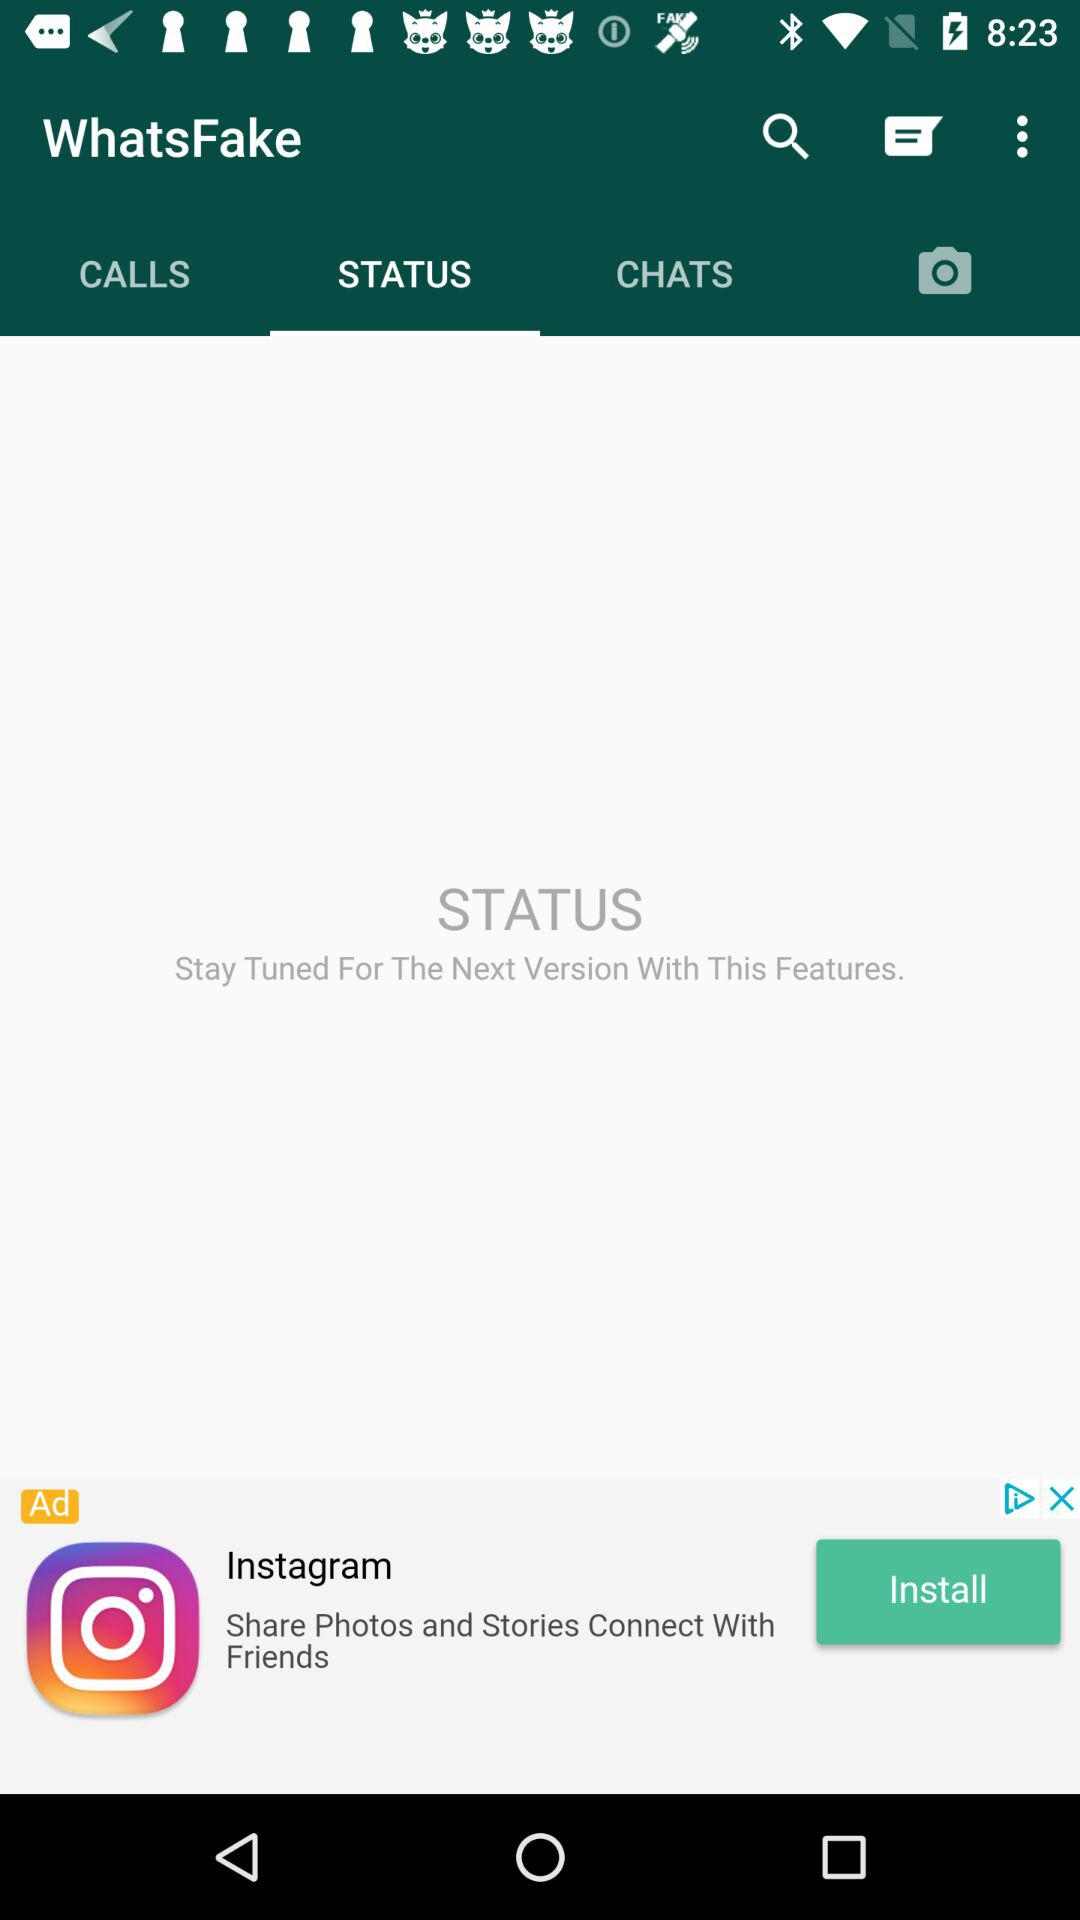Which tab is selected? The selected tab is "STATUS". 